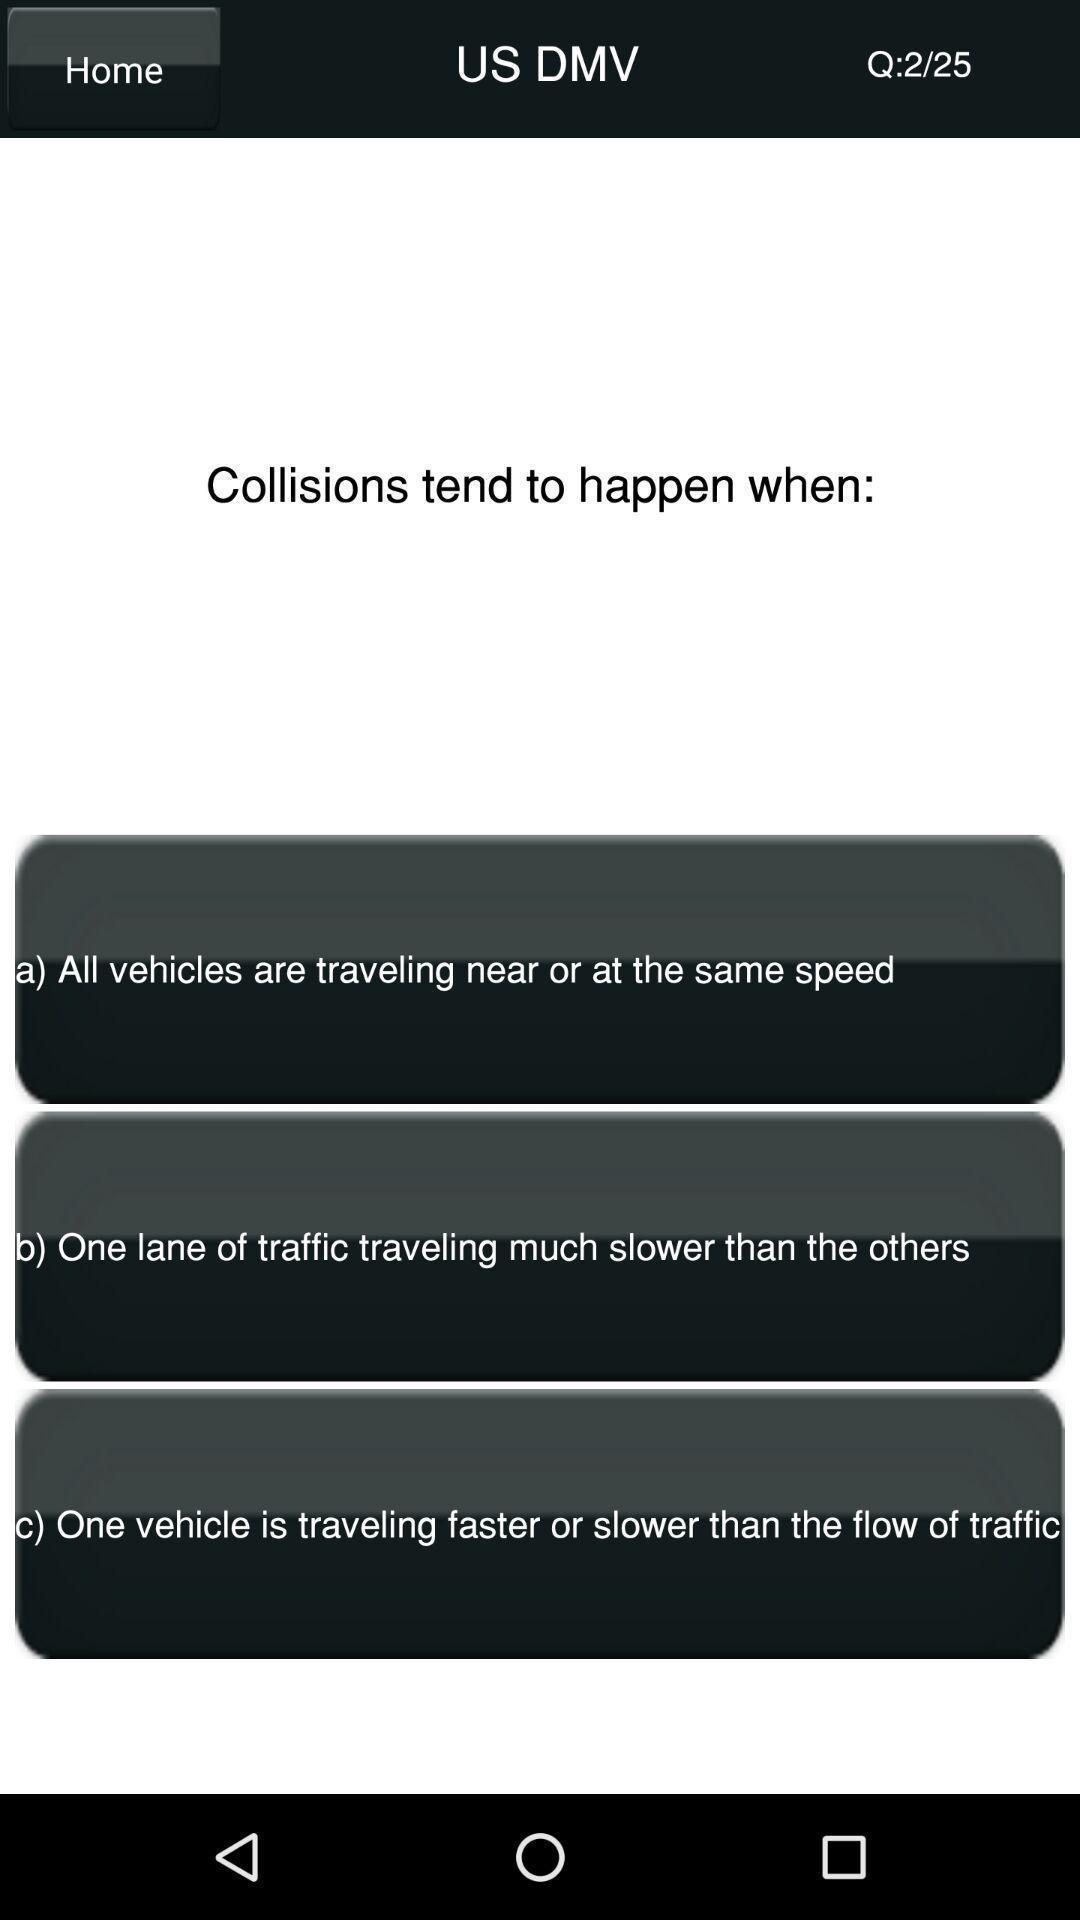Give me a summary of this screen capture. Page of an education app. 